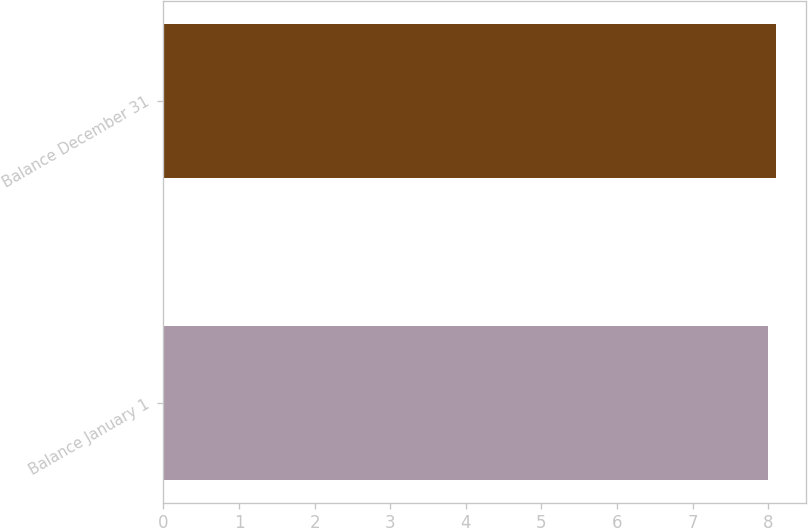Convert chart. <chart><loc_0><loc_0><loc_500><loc_500><bar_chart><fcel>Balance January 1<fcel>Balance December 31<nl><fcel>8<fcel>8.1<nl></chart> 